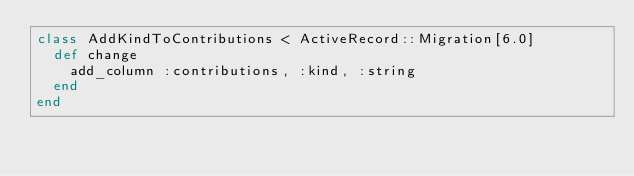<code> <loc_0><loc_0><loc_500><loc_500><_Ruby_>class AddKindToContributions < ActiveRecord::Migration[6.0]
  def change
    add_column :contributions, :kind, :string
  end
end</code> 